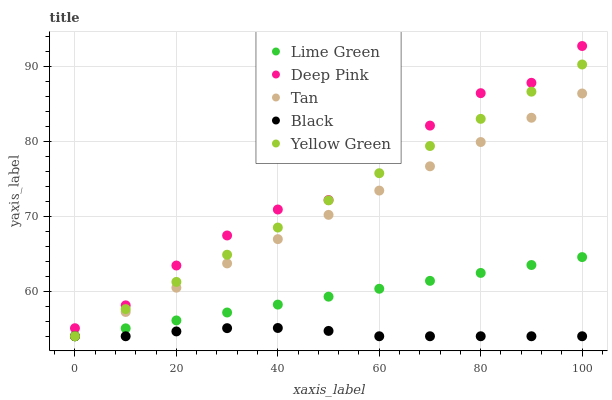Does Black have the minimum area under the curve?
Answer yes or no. Yes. Does Deep Pink have the maximum area under the curve?
Answer yes or no. Yes. Does Tan have the minimum area under the curve?
Answer yes or no. No. Does Tan have the maximum area under the curve?
Answer yes or no. No. Is Lime Green the smoothest?
Answer yes or no. Yes. Is Deep Pink the roughest?
Answer yes or no. Yes. Is Tan the smoothest?
Answer yes or no. No. Is Tan the roughest?
Answer yes or no. No. Does Black have the lowest value?
Answer yes or no. Yes. Does Deep Pink have the lowest value?
Answer yes or no. No. Does Deep Pink have the highest value?
Answer yes or no. Yes. Does Tan have the highest value?
Answer yes or no. No. Is Lime Green less than Deep Pink?
Answer yes or no. Yes. Is Deep Pink greater than Black?
Answer yes or no. Yes. Does Yellow Green intersect Black?
Answer yes or no. Yes. Is Yellow Green less than Black?
Answer yes or no. No. Is Yellow Green greater than Black?
Answer yes or no. No. Does Lime Green intersect Deep Pink?
Answer yes or no. No. 